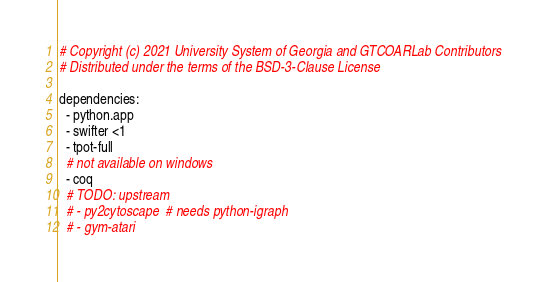Convert code to text. <code><loc_0><loc_0><loc_500><loc_500><_YAML_># Copyright (c) 2021 University System of Georgia and GTCOARLab Contributors
# Distributed under the terms of the BSD-3-Clause License

dependencies:
  - python.app
  - swifter <1
  - tpot-full
  # not available on windows
  - coq
  # TODO: upstream
  # - py2cytoscape  # needs python-igraph
  # - gym-atari
</code> 